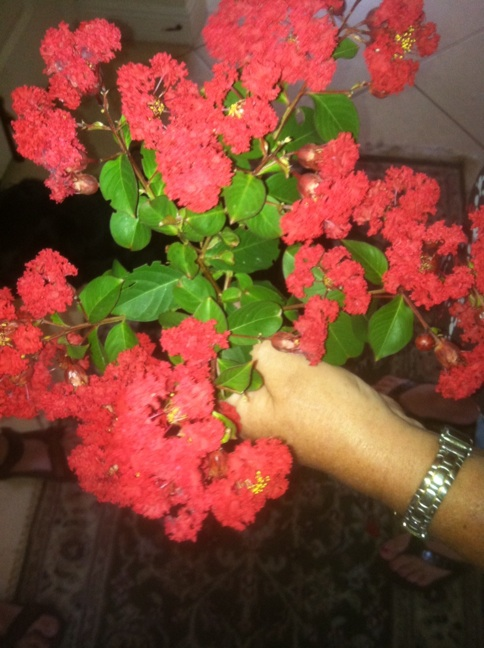How long do these flowers typically bloom? Crape myrtle flowers can bloom for up to three to four months during the warm season, usually starting from late spring to early fall. This long blooming period makes them highly appealing for gardens and public areas. 